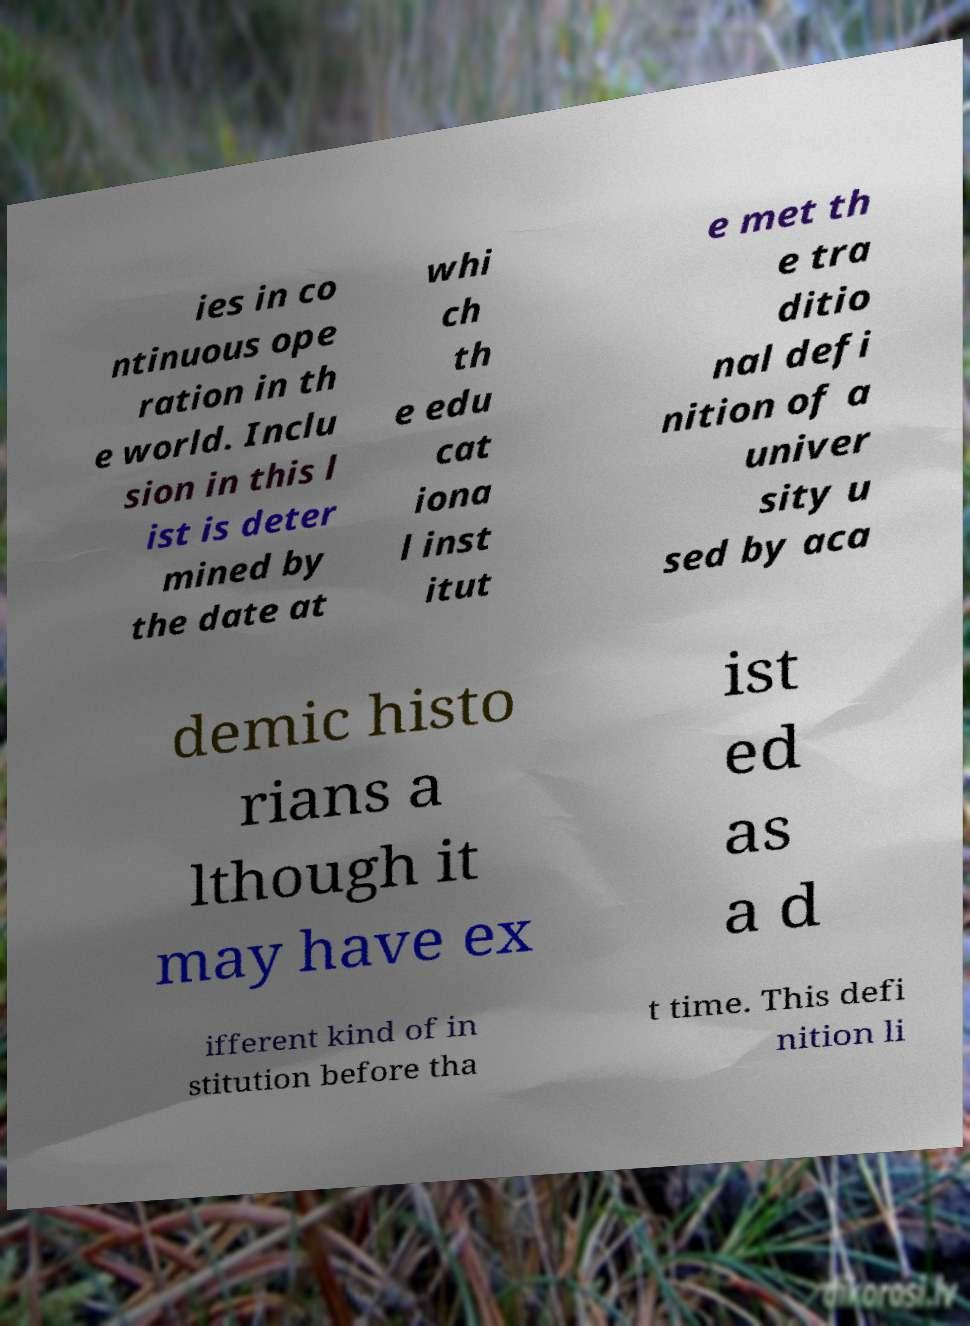I need the written content from this picture converted into text. Can you do that? ies in co ntinuous ope ration in th e world. Inclu sion in this l ist is deter mined by the date at whi ch th e edu cat iona l inst itut e met th e tra ditio nal defi nition of a univer sity u sed by aca demic histo rians a lthough it may have ex ist ed as a d ifferent kind of in stitution before tha t time. This defi nition li 